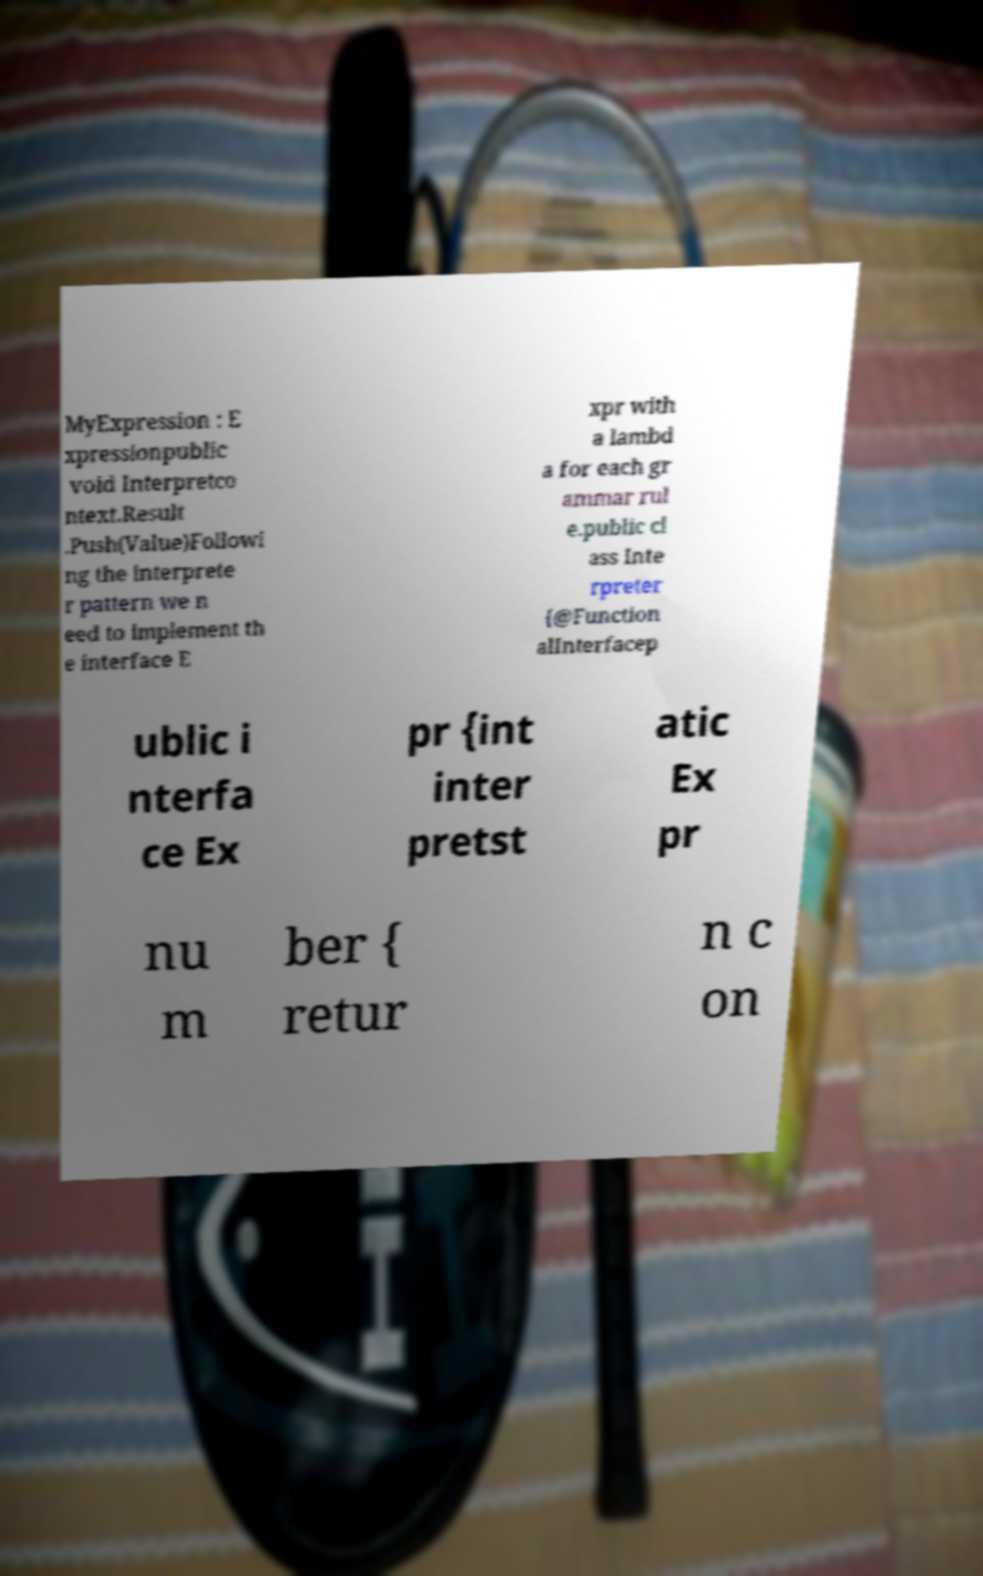Can you accurately transcribe the text from the provided image for me? MyExpression : E xpressionpublic void Interpretco ntext.Result .Push(Value)Followi ng the interprete r pattern we n eed to implement th e interface E xpr with a lambd a for each gr ammar rul e.public cl ass Inte rpreter {@Function alInterfacep ublic i nterfa ce Ex pr {int inter pretst atic Ex pr nu m ber { retur n c on 